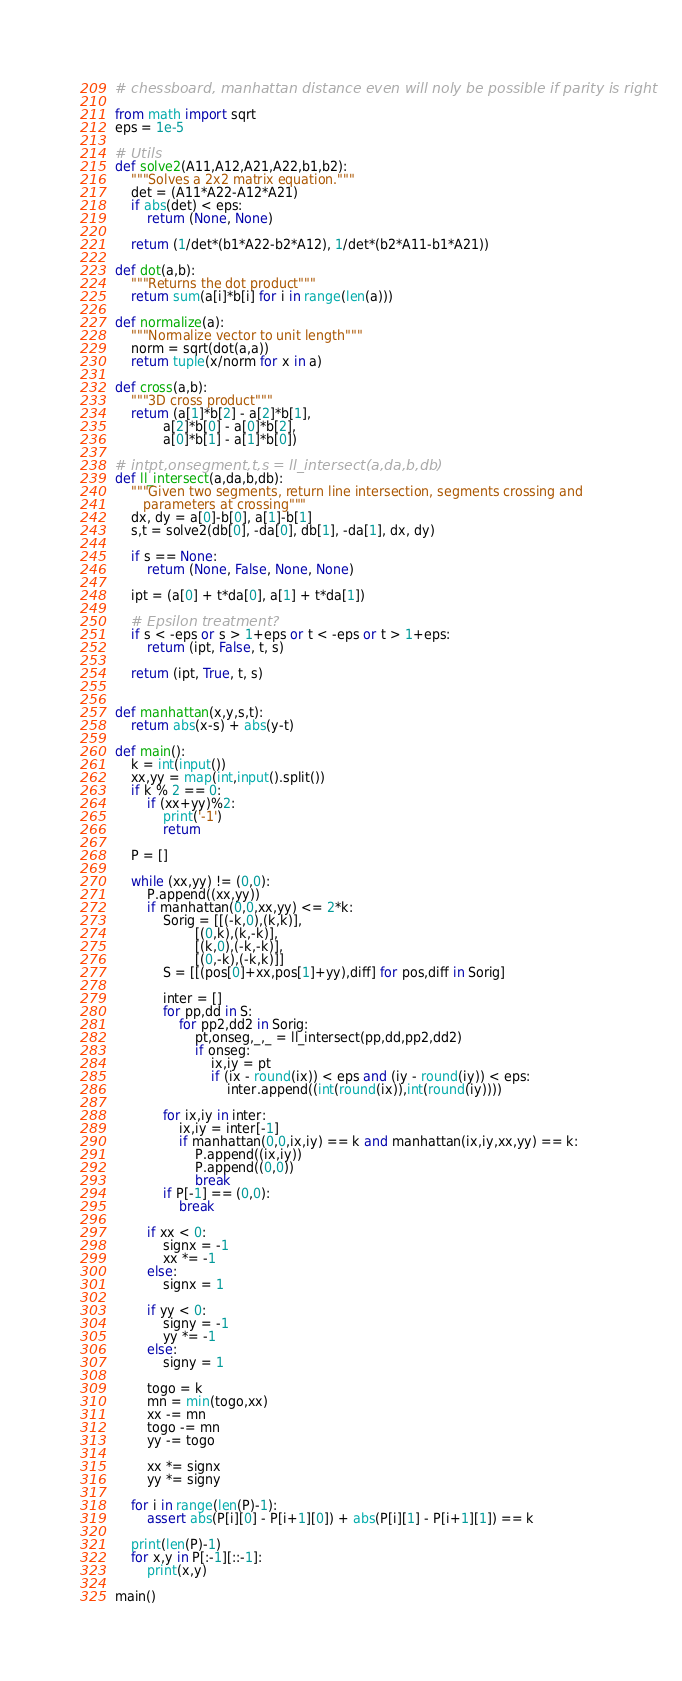<code> <loc_0><loc_0><loc_500><loc_500><_Python_># chessboard, manhattan distance even will noly be possible if parity is right

from math import sqrt
eps = 1e-5

# Utils
def solve2(A11,A12,A21,A22,b1,b2):
    """Solves a 2x2 matrix equation."""
    det = (A11*A22-A12*A21)
    if abs(det) < eps:
        return (None, None)

    return (1/det*(b1*A22-b2*A12), 1/det*(b2*A11-b1*A21))

def dot(a,b):
    """Returns the dot product"""
    return sum(a[i]*b[i] for i in range(len(a)))
    
def normalize(a):
    """Normalize vector to unit length"""
    norm = sqrt(dot(a,a))
    return tuple(x/norm for x in a)

def cross(a,b):
    """3D cross product"""
    return (a[1]*b[2] - a[2]*b[1],
            a[2]*b[0] - a[0]*b[2],
            a[0]*b[1] - a[1]*b[0])

# intpt,onsegment,t,s = ll_intersect(a,da,b,db)
def ll_intersect(a,da,b,db):
    """Given two segments, return line intersection, segments crossing and
       parameters at crossing"""
    dx, dy = a[0]-b[0], a[1]-b[1]
    s,t = solve2(db[0], -da[0], db[1], -da[1], dx, dy)

    if s == None:
        return (None, False, None, None)

    ipt = (a[0] + t*da[0], a[1] + t*da[1])
    
    # Epsilon treatment?
    if s < -eps or s > 1+eps or t < -eps or t > 1+eps:
        return (ipt, False, t, s)
    
    return (ipt, True, t, s)
    

def manhattan(x,y,s,t):
    return abs(x-s) + abs(y-t)

def main():
    k = int(input())
    xx,yy = map(int,input().split())
    if k % 2 == 0:
        if (xx+yy)%2:
            print('-1')
            return
    
    P = []

    while (xx,yy) != (0,0):
        P.append((xx,yy))
        if manhattan(0,0,xx,yy) <= 2*k:
            Sorig = [[(-k,0),(k,k)],
                    [(0,k),(k,-k)],
                    [(k,0),(-k,-k)],
                    [(0,-k),(-k,k)]]
            S = [[(pos[0]+xx,pos[1]+yy),diff] for pos,diff in Sorig]
            
            inter = []
            for pp,dd in S:
                for pp2,dd2 in Sorig:
                    pt,onseg,_,_ = ll_intersect(pp,dd,pp2,dd2)
                    if onseg:
                        ix,iy = pt
                        if (ix - round(ix)) < eps and (iy - round(iy)) < eps:
                            inter.append((int(round(ix)),int(round(iy))))

            for ix,iy in inter:
                ix,iy = inter[-1]
                if manhattan(0,0,ix,iy) == k and manhattan(ix,iy,xx,yy) == k:
                    P.append((ix,iy))
                    P.append((0,0))
                    break
            if P[-1] == (0,0):
                break

        if xx < 0:
            signx = -1
            xx *= -1
        else:
            signx = 1

        if yy < 0:
            signy = -1
            yy *= -1
        else:
            signy = 1

        togo = k
        mn = min(togo,xx)
        xx -= mn
        togo -= mn
        yy -= togo

        xx *= signx
        yy *= signy

    for i in range(len(P)-1):
        assert abs(P[i][0] - P[i+1][0]) + abs(P[i][1] - P[i+1][1]) == k

    print(len(P)-1)
    for x,y in P[:-1][::-1]:
        print(x,y)

main()
</code> 